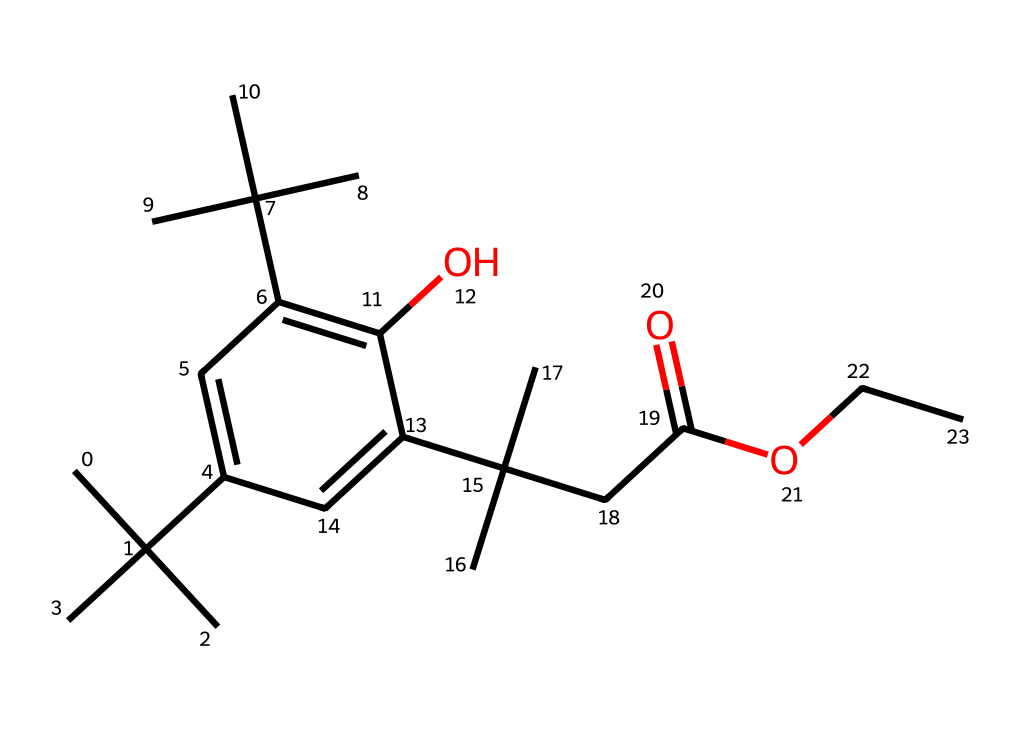What is the total number of carbon atoms in this chemical? Counting the carbon (C) atoms represented in the SMILES notation shows the branches and the aromatic ring structure. There are 18 carbon atoms in total.
Answer: 18 How many hydroxyl (OH) groups are present in this structure? The presence of the hydroxyl (OH) groups can be seen by identifying where an oxygen (O) is bonded to a hydrogen (H). In this structure, there is one hydroxyl group.
Answer: 1 What functional group is indicated by the ending part "OCC"? The part "OCC" indicates an ether functional group due to the presence of an oxygen (O) atom connected to two carbon (C) chains.
Answer: ether What type of compound does this structure primarily represent? The presence of multiple branching alkyl groups and functional groups suggests that this compound is primarily an alcohol or ester. Given its structure and potential for photoresist applications, it is classified as a photoresist compound.
Answer: photoresist What effect do the branched alkyl groups have on the chemical's properties? The branched alkyl groups increase the steric hindrance and hydrophobic characteristics, which enhance the UV resistance and durability of the chemical.
Answer: increase UV resistance What is the significance of the carboxylic acid group in this chemical? The carboxylic acid group (-COOH), found in the structure, plays a crucial role in increasing adhesion and compatibility with various substrates within outdoor environments.
Answer: adhesion 